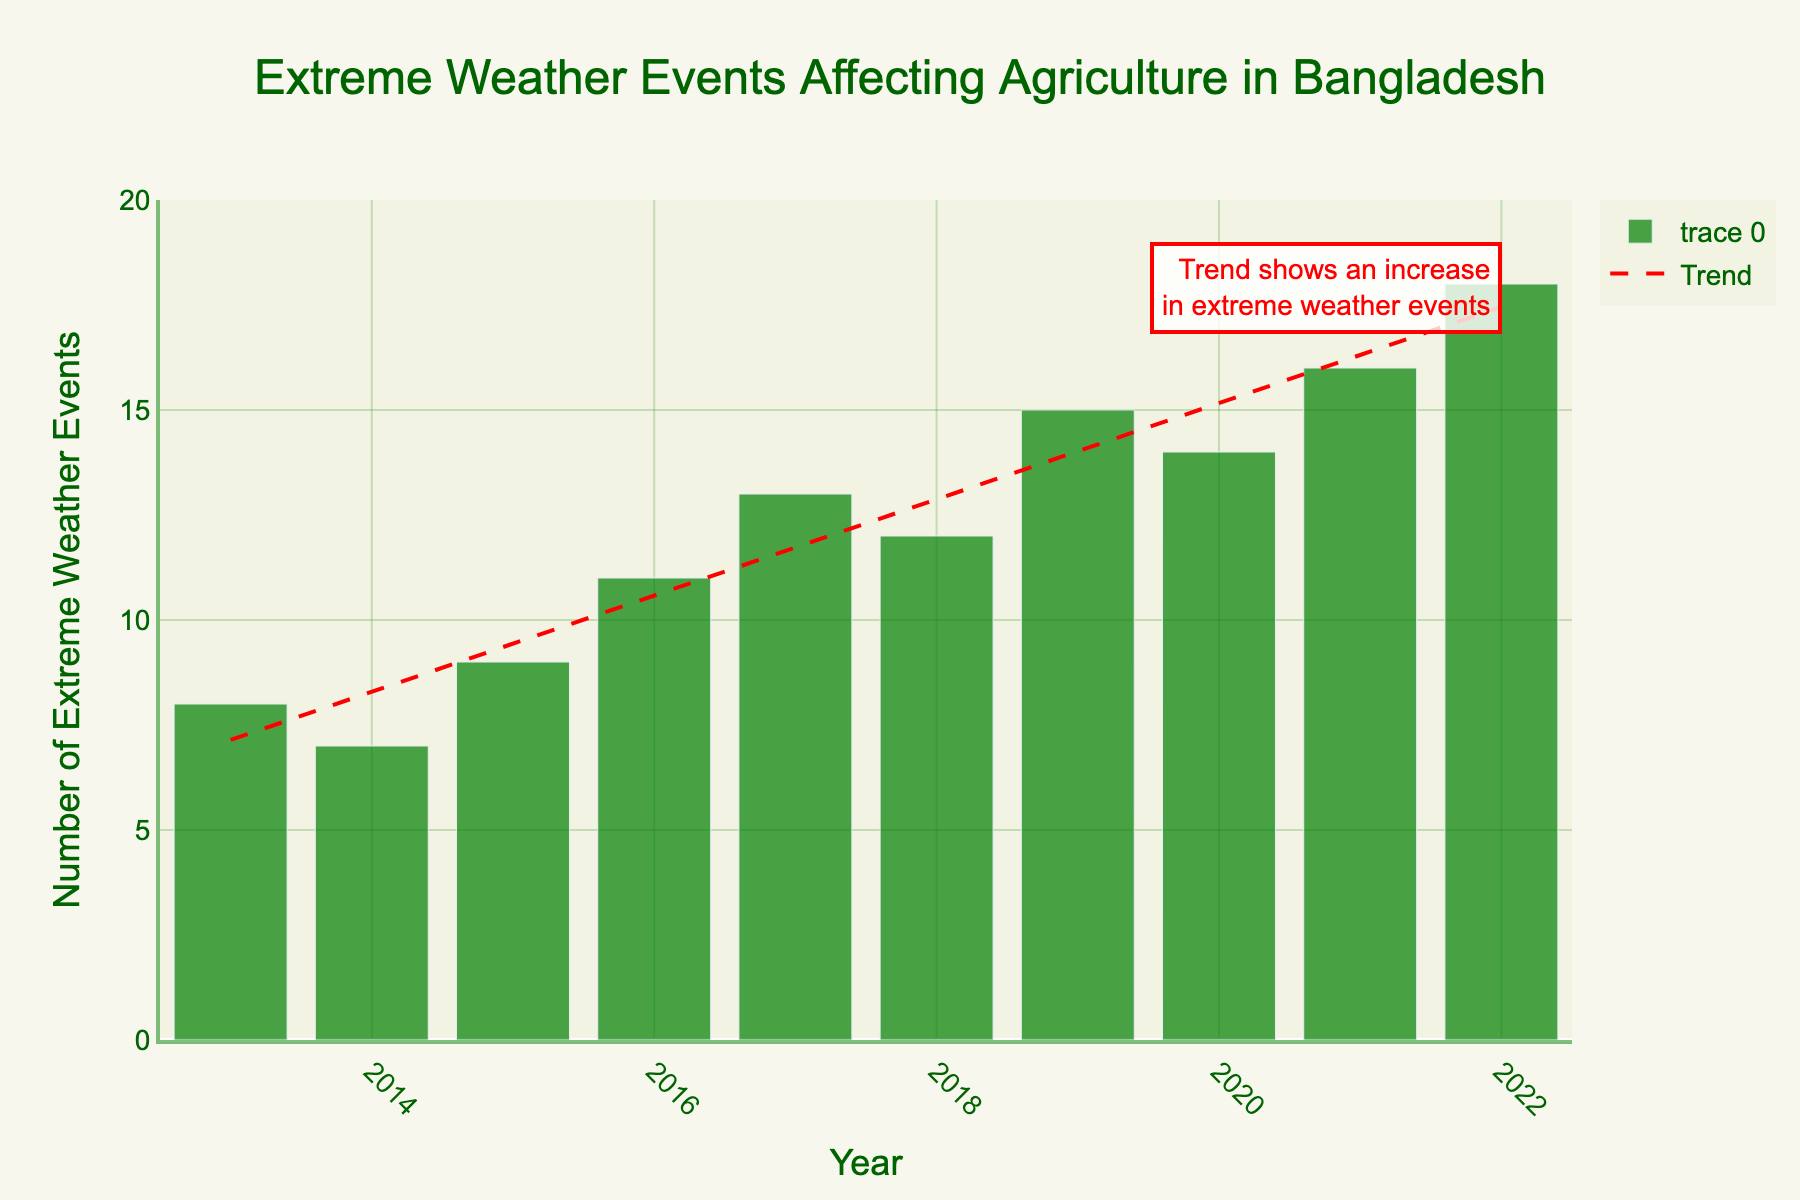Which year had the highest number of extreme weather events affecting agriculture? The bar for the year 2022 reaches the highest point, representing 18 extreme weather events.
Answer: 2022 Is there a clear trend in the number of extreme weather events affecting agriculture over the years? The red trend line in the chart indicates an upward slope, showing an increase in extreme weather events over the years.
Answer: Yes What is the average number of extreme weather events from 2013 to 2022? Add the numbers from 2013 to 2022 (8+7+9+11+13+12+15+14+16+18=123) and then divide by the number of years (10).
Answer: 12.3 By how much did the number of extreme weather events increase from 2013 to 2022? Subtract the number of events in 2013 (8) from that in 2022 (18).
Answer: 10 Which year had fewer events: 2015 or 2018? Compare the heights of the bars for 2015 and 2018. The bar for 2015 shows 9 events, and the bar for 2018 shows 12 events.
Answer: 2015 What is the total number of extreme weather events over the 10-year period? Sum all the numbers from 2013 to 2022 (8+7+9+11+13+12+15+14+16+18).
Answer: 123 Did the number of extreme weather events ever decrease from one year to the next? Compare the heights of consecutive bars. From 2017 to 2018, the number decreased from 13 to 12.
Answer: Yes Which two years had the closest number of extreme weather events? Compare the differences between consecutive years. The difference between 2020 (14 events) and 2019 (15 events) is 1, which is the smallest difference.
Answer: 2019 and 2020 What is the median number of extreme weather events over the decade? List the numbers in ascending order (7, 8, 9, 11, 12, 13, 14, 15, 16, 18). The median is the average of the 5th and 6th numbers (12 and 13), which is (12+13)/2.
Answer: 12.5 